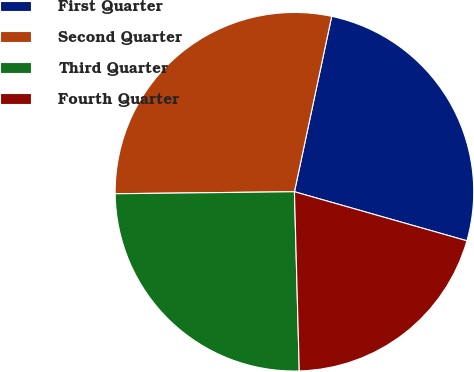<chart> <loc_0><loc_0><loc_500><loc_500><pie_chart><fcel>First Quarter<fcel>Second Quarter<fcel>Third Quarter<fcel>Fourth Quarter<nl><fcel>26.08%<fcel>28.51%<fcel>25.25%<fcel>20.16%<nl></chart> 